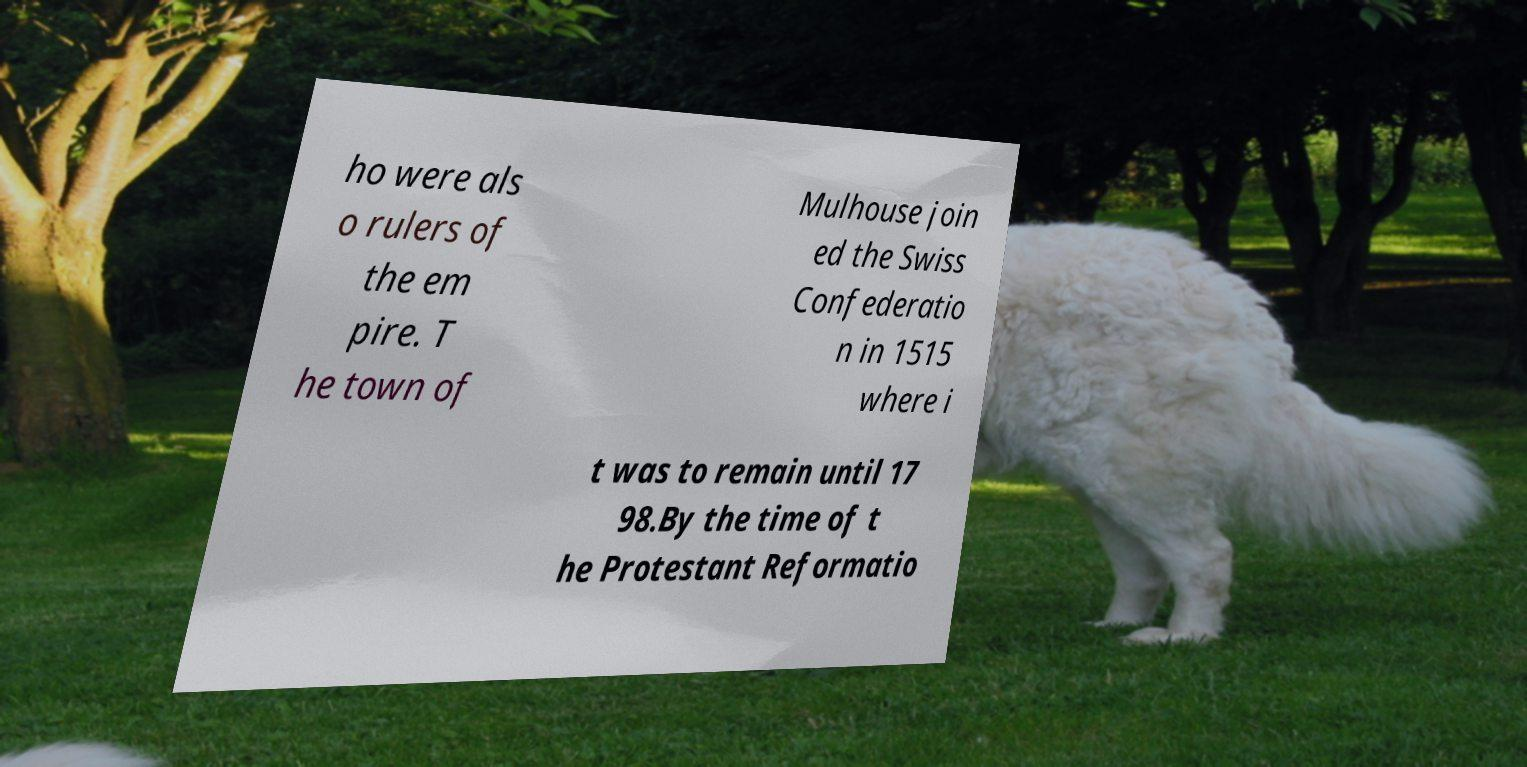Could you assist in decoding the text presented in this image and type it out clearly? ho were als o rulers of the em pire. T he town of Mulhouse join ed the Swiss Confederatio n in 1515 where i t was to remain until 17 98.By the time of t he Protestant Reformatio 